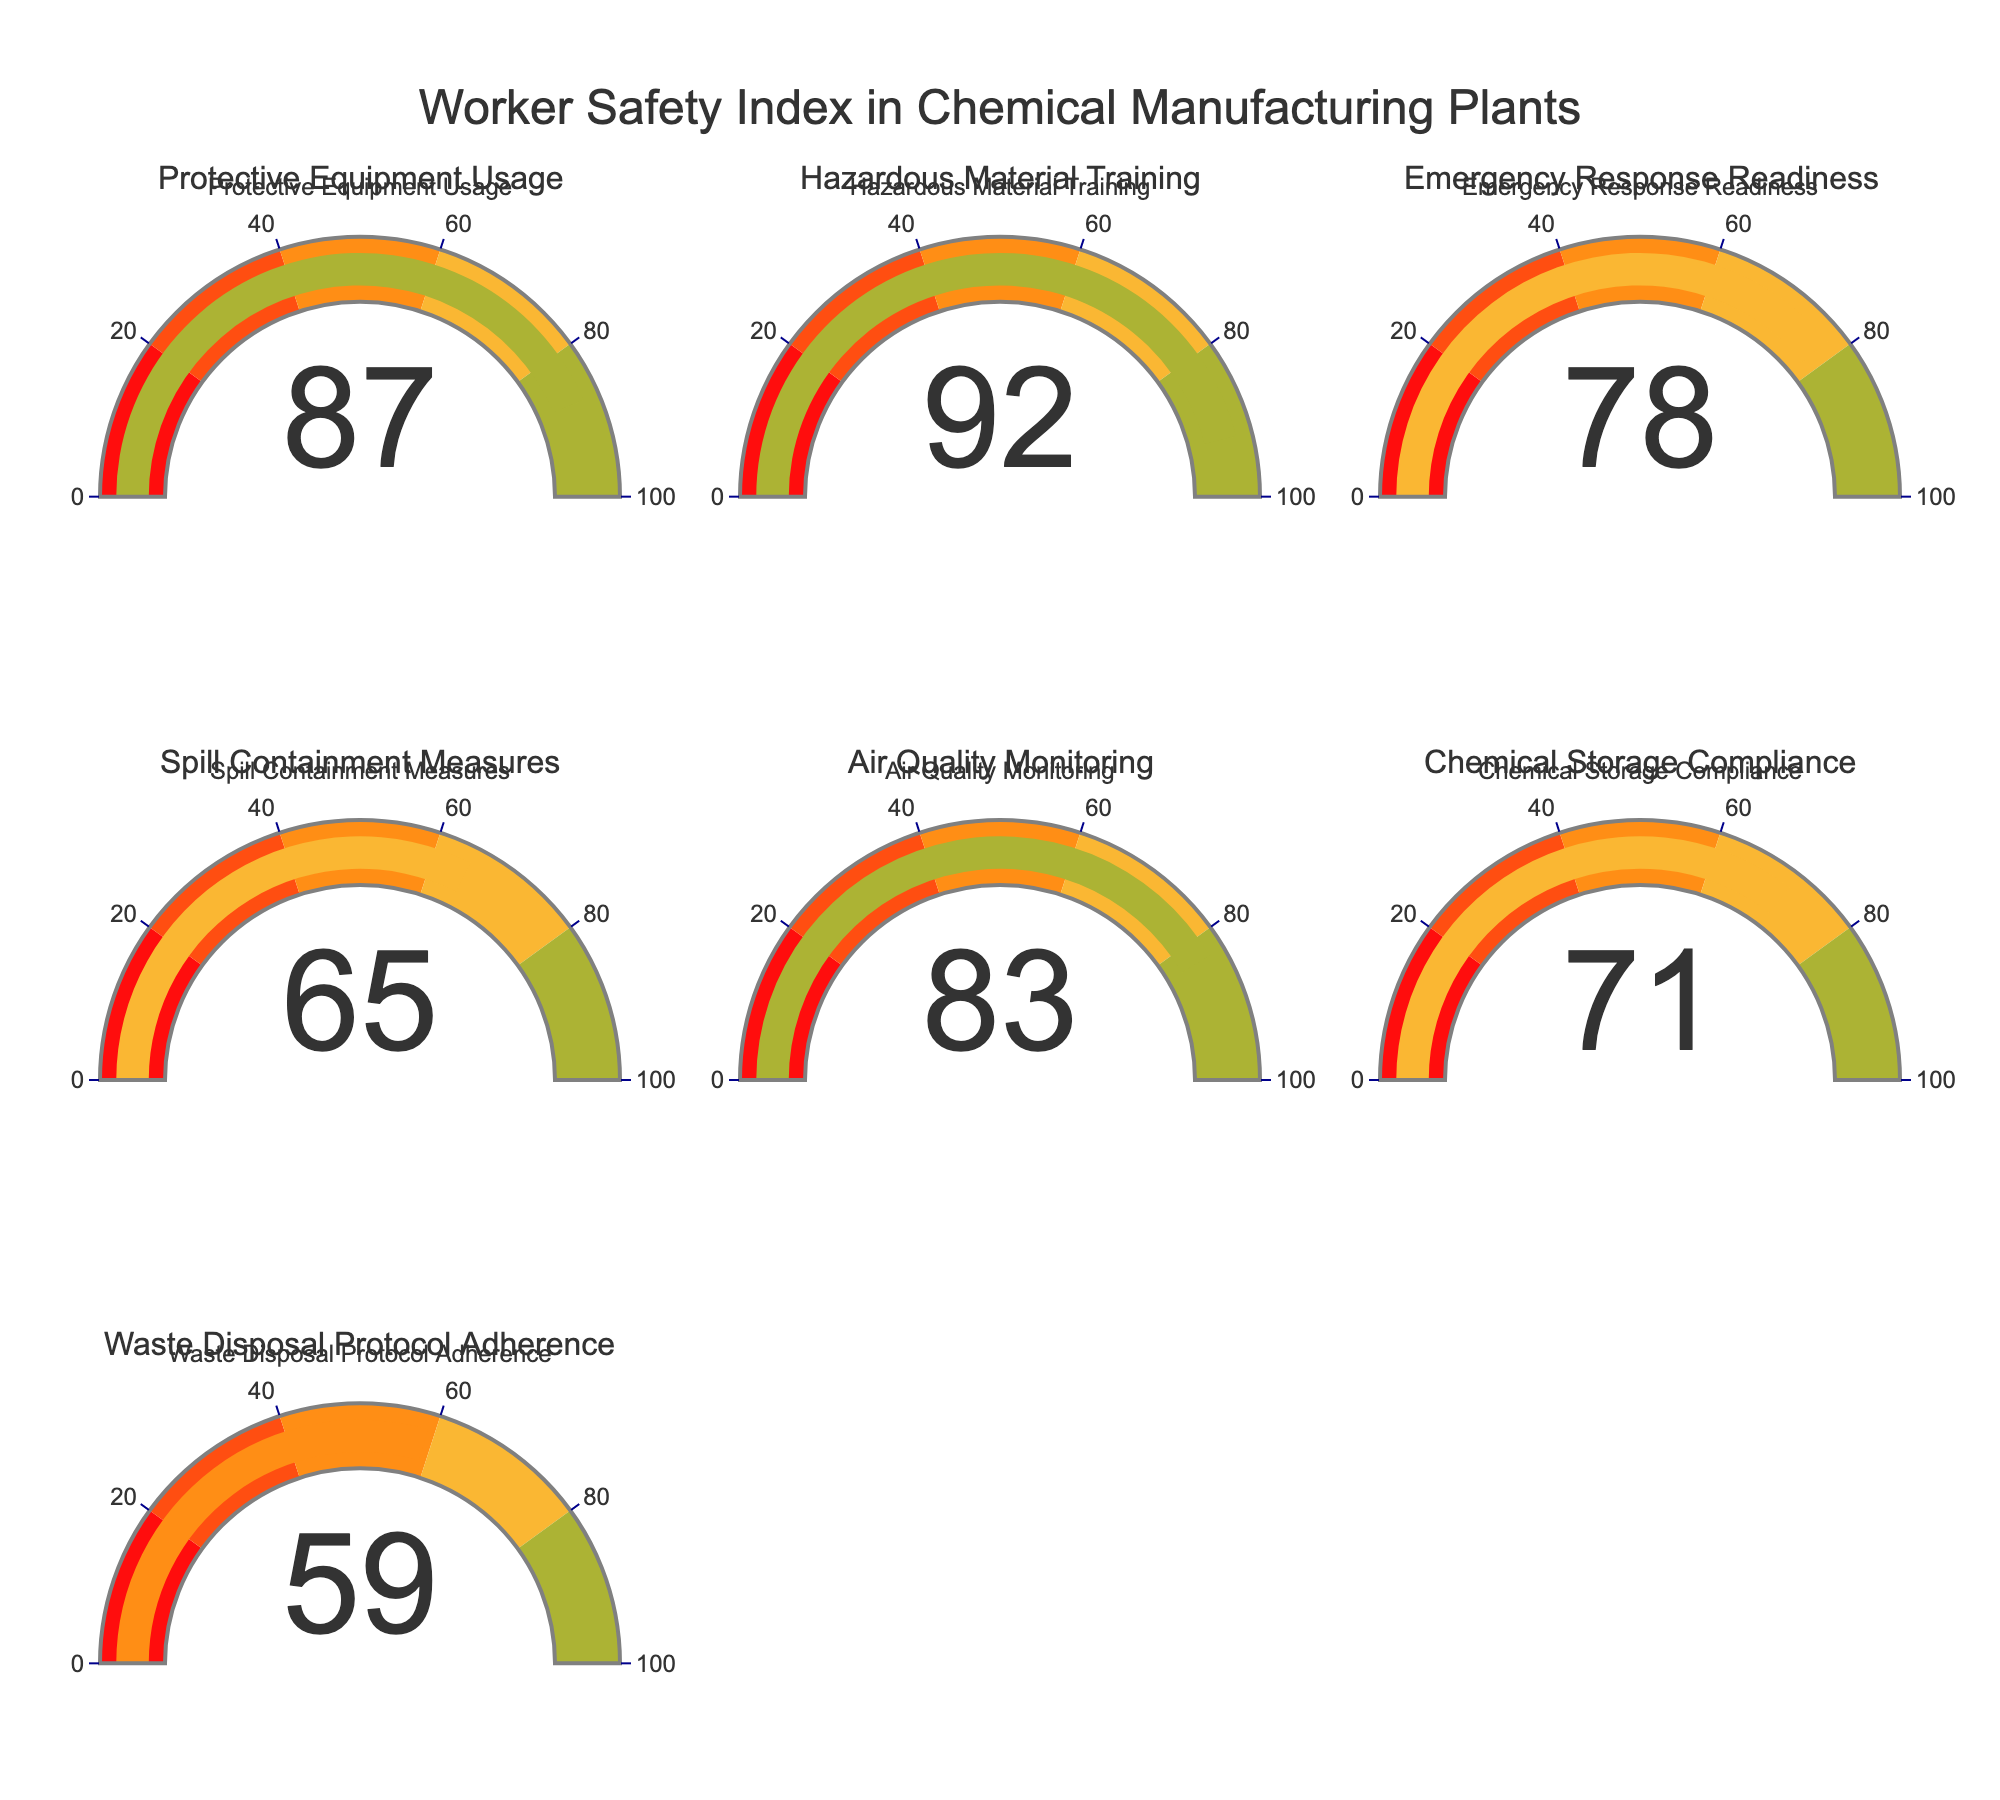**Basic Question**: What is the title of the gauge chart? The title is located at the top of the figure. It clearly states the main subject of the figure.
Answer: Worker Safety Index in Chemical Manufacturing Plants **Comparison Question**: Which safety index has the highest value? By looking at the gauge values, identify the one with the highest numerical value.
Answer: Hazardous Material Training **Comparison Question**: Which index has the lowest value? By comparing the values displayed on all gauges, determine which one is the smallest. The value of 59 is the lowest.
Answer: Waste Disposal Protocol Adherence **Chart-Type Specific Question**: What color represents the “Spill Containment Measures” index? Identify the chart labeled “Spill Containment Measures” and observe the color of the gauge bar. It’s in the 60-80 range.
Answer: Yellow **Compositional Question**: What is the average value of all indices? Sum all the values (87 + 92 + 78 + 65 + 83 + 71 + 59 = 535) and divide by the number of indices (7). The average is 535/7.
Answer: 76.43 **Comparison Question**: How many indices have a value above 80? Count the indices where the gauge value exceeds 80. There are three: Protective Equipment Usage (87), Hazardous Material Training (92), and Air Quality Monitoring (83).
Answer: 3 **Chart-Type Specific Question**: What is the value displayed on the “Emergency Response Readiness” gauge? Locate the “Emergency Response Readiness” label and read the gauge value.
Answer: 78 **Compositional Question**: What is the difference between the highest value and the lowest value? Subtract the lowest value (59) from the highest value (92) to find the range difference.
Answer: 33 **Comparison Question**: Which indexes are in the range of 60 to 80? Identify values in the 60-80 range. There are three: “Emergency Response Readiness” (78), “Spill Containment Measures” (65), and “Chemical Storage Compliance” (71).
Answer: Emergency Response Readiness, Spill Containment Measures, Chemical Storage Compliance 